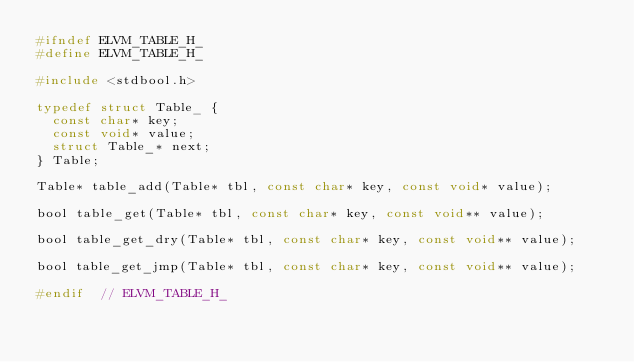Convert code to text. <code><loc_0><loc_0><loc_500><loc_500><_C_>#ifndef ELVM_TABLE_H_
#define ELVM_TABLE_H_

#include <stdbool.h>

typedef struct Table_ {
  const char* key;
  const void* value;
  struct Table_* next;
} Table;

Table* table_add(Table* tbl, const char* key, const void* value);

bool table_get(Table* tbl, const char* key, const void** value);

bool table_get_dry(Table* tbl, const char* key, const void** value);

bool table_get_jmp(Table* tbl, const char* key, const void** value);

#endif  // ELVM_TABLE_H_
</code> 